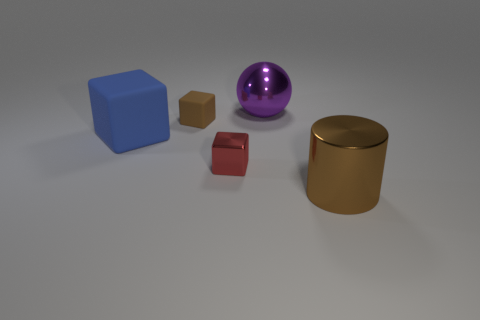Subtract all blue blocks. How many blocks are left? 2 Subtract all cylinders. How many objects are left? 4 Add 4 gray matte spheres. How many objects exist? 9 Subtract 0 green cylinders. How many objects are left? 5 Subtract all gray cubes. Subtract all cyan spheres. How many cubes are left? 3 Subtract all small shiny cubes. Subtract all large blue matte cubes. How many objects are left? 3 Add 1 brown things. How many brown things are left? 3 Add 5 tiny blue things. How many tiny blue things exist? 5 